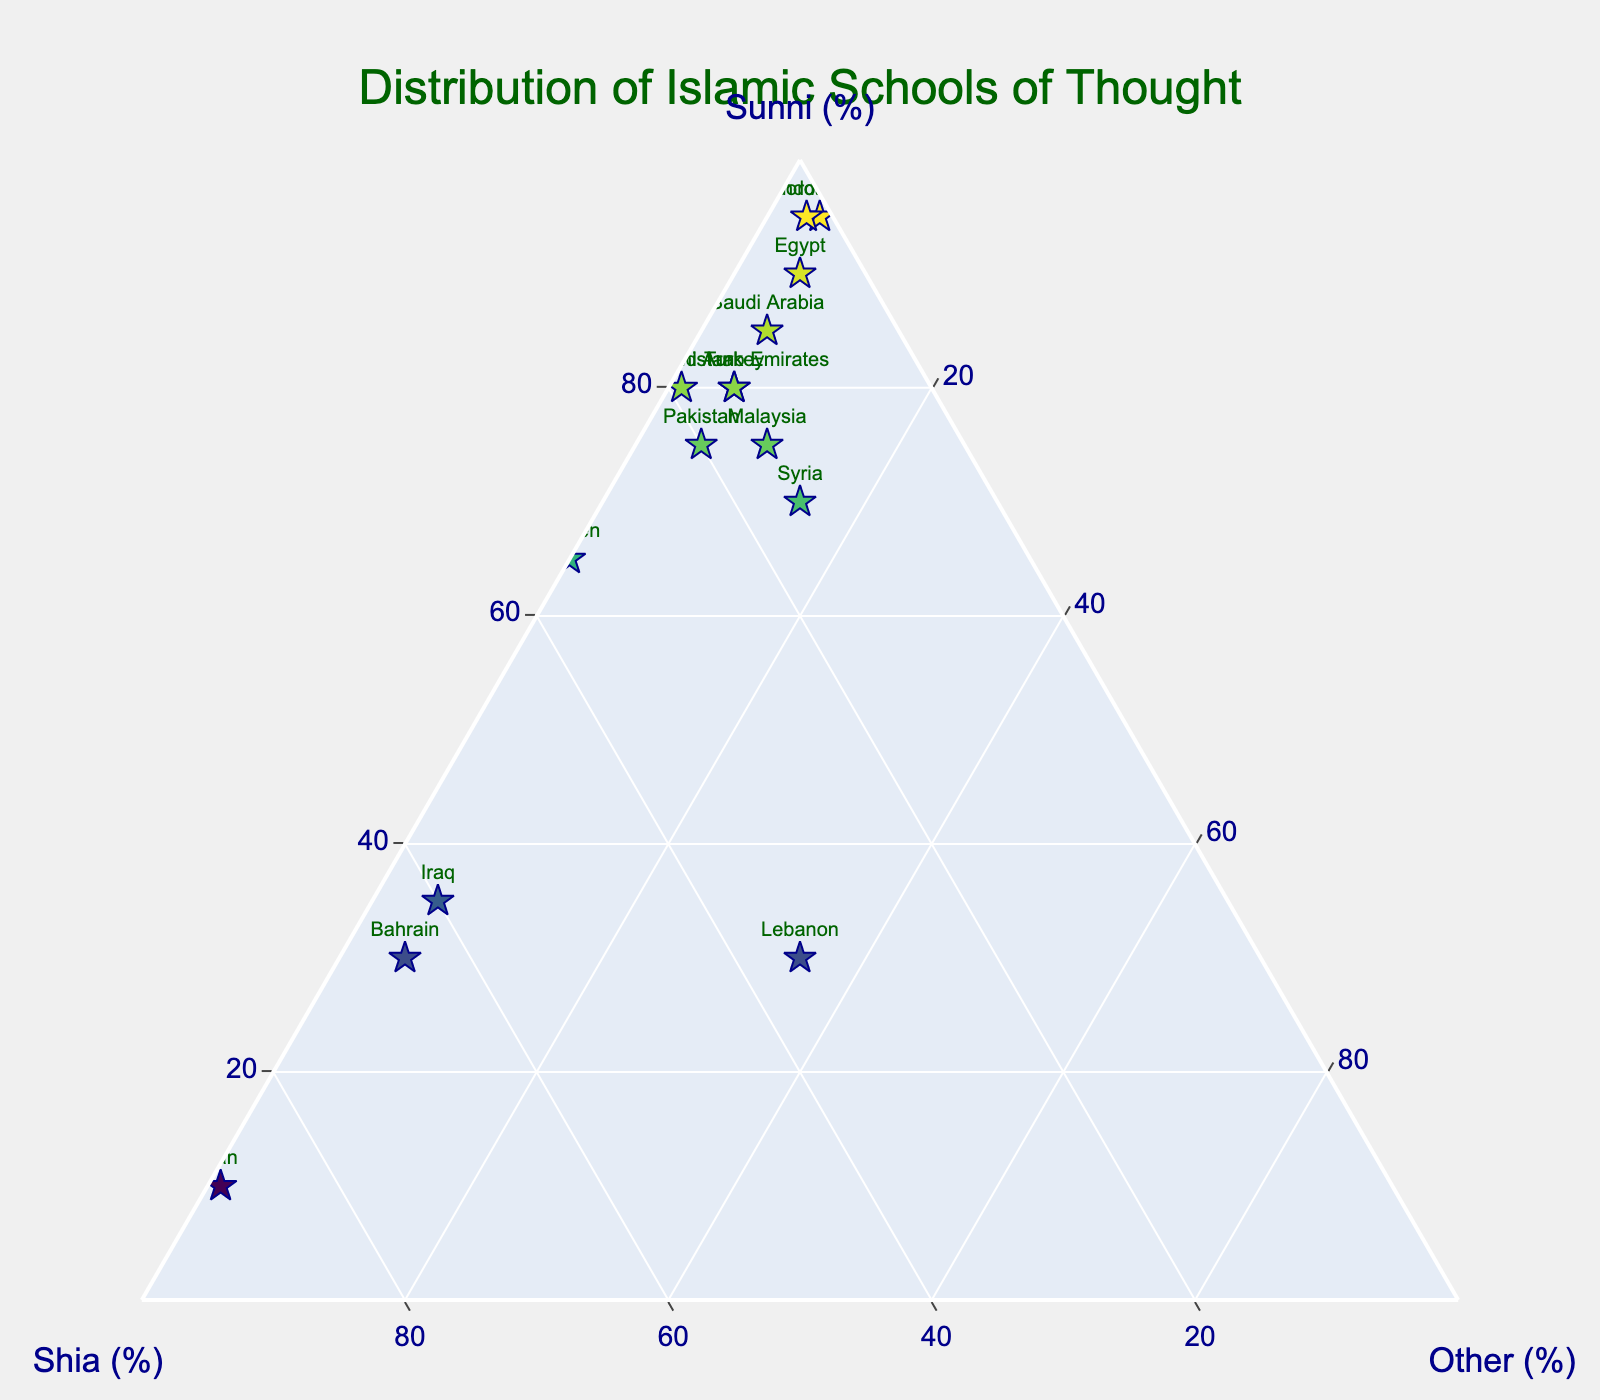Which country has the highest proportion of Sunni Muslims? To determine the country with the highest proportion of Sunni Muslims, look for the data point placed furthest towards the 'Sunni (%)' axis. Indonesia is highest with 95%.
Answer: Indonesia What percentage of the population in Iran are Shia Muslims? Locate Iran on the plot, and refer to its position in relation to the 'Shia (%)' axis. Iran’s data point is near the top of the Shia axis.
Answer: 89% How many countries have a higher percentage of 'Other' Muslims compared to Shia Muslims? Check each country's coordinates to see if the 'Other (%)' value is greater than the 'Shia (%)' value. Only Lebanon fits this criterion.
Answer: 1 Which country has an equal percentage distribution between Sunni and Shia Muslims? Find a point that lies along the line where 'Sunni (%)' equals 'Shia (%)'. No country has equal distribution.
Answer: None What's the combined percentage of Sunni and Shia Muslims in Malaysia? Add the Sunni and Shia percentages for Malaysia: 75 (Sunni) + 15 (Shia) = 90
Answer: 90% Compare the proportions of Sunni Muslims in Turkey and Pakistan. Which country has a higher percentage? Check Turkey and Pakistan on the plot and compare their 'Sunni (%)' values. Turkey has 80% and Pakistan has 75%.
Answer: Turkey Which country has the closest proportions of Sunni, Shia, and Other Muslims? Look for a point somewhat centered within the ternary plot. Lebanon has 30% Sunni, 35% Shia, and 35% Other, making it the closest to an even distribution.
Answer: Lebanon What is the difference between the percentages of Sunni and Shia Muslims in Yemen? Subtract the Shia percentage from the Sunni percentage for Yemen: 65 (Sunni) - 35 (Shia) = 30
Answer: 30% What is the main Islamic denomination in Iraq? Locate Iraq and observe which percentage is the largest. Iraq's Shia percentage (60%) is the highest compared to Sunni (35%) and Other (5%).
Answer: Shia 